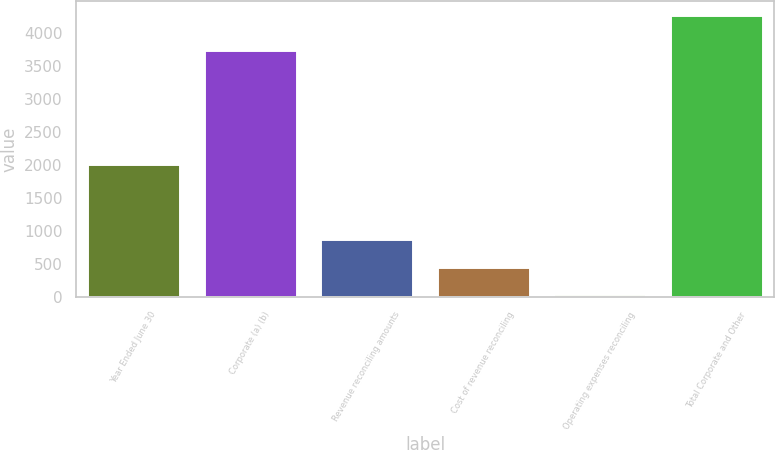Convert chart to OTSL. <chart><loc_0><loc_0><loc_500><loc_500><bar_chart><fcel>Year Ended June 30<fcel>Corporate (a) (b)<fcel>Revenue reconciling amounts<fcel>Cost of revenue reconciling<fcel>Operating expenses reconciling<fcel>Total Corporate and Other<nl><fcel>2014<fcel>3744<fcel>887.4<fcel>463.7<fcel>40<fcel>4277<nl></chart> 